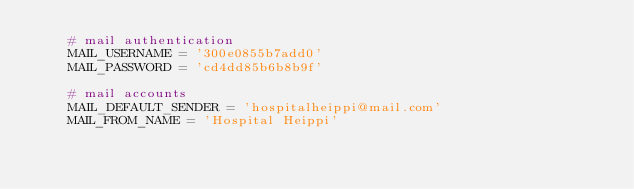<code> <loc_0><loc_0><loc_500><loc_500><_Python_>    # mail authentication
    MAIL_USERNAME = '300e0855b7add0'
    MAIL_PASSWORD = 'cd4dd85b6b8b9f'

    # mail accounts
    MAIL_DEFAULT_SENDER = 'hospitalheippi@mail.com'
    MAIL_FROM_NAME = 'Hospital Heippi'</code> 